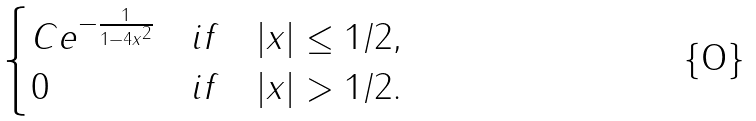Convert formula to latex. <formula><loc_0><loc_0><loc_500><loc_500>\begin{cases} C e ^ { - { \frac { 1 } { 1 - 4 x ^ { 2 } } } } & i f \quad | x | \leq 1 / 2 , \\ 0 & i f \quad | x | > 1 / 2 . \end{cases}</formula> 